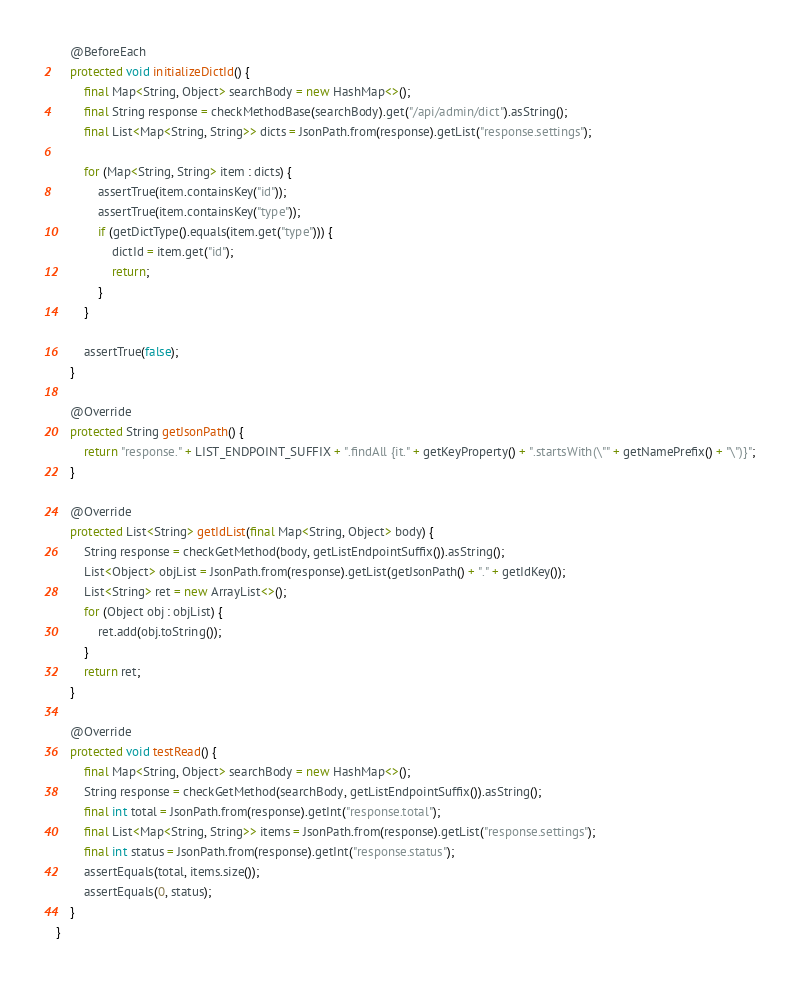<code> <loc_0><loc_0><loc_500><loc_500><_Java_>    @BeforeEach
    protected void initializeDictId() {
        final Map<String, Object> searchBody = new HashMap<>();
        final String response = checkMethodBase(searchBody).get("/api/admin/dict").asString();
        final List<Map<String, String>> dicts = JsonPath.from(response).getList("response.settings");

        for (Map<String, String> item : dicts) {
            assertTrue(item.containsKey("id"));
            assertTrue(item.containsKey("type"));
            if (getDictType().equals(item.get("type"))) {
                dictId = item.get("id");
                return;
            }
        }

        assertTrue(false);
    }

    @Override
    protected String getJsonPath() {
        return "response." + LIST_ENDPOINT_SUFFIX + ".findAll {it." + getKeyProperty() + ".startsWith(\"" + getNamePrefix() + "\")}";
    }

    @Override
    protected List<String> getIdList(final Map<String, Object> body) {
        String response = checkGetMethod(body, getListEndpointSuffix()).asString();
        List<Object> objList = JsonPath.from(response).getList(getJsonPath() + "." + getIdKey());
        List<String> ret = new ArrayList<>();
        for (Object obj : objList) {
            ret.add(obj.toString());
        }
        return ret;
    }

    @Override
    protected void testRead() {
        final Map<String, Object> searchBody = new HashMap<>();
        String response = checkGetMethod(searchBody, getListEndpointSuffix()).asString();
        final int total = JsonPath.from(response).getInt("response.total");
        final List<Map<String, String>> items = JsonPath.from(response).getList("response.settings");
        final int status = JsonPath.from(response).getInt("response.status");
        assertEquals(total, items.size());
        assertEquals(0, status);
    }
}
</code> 